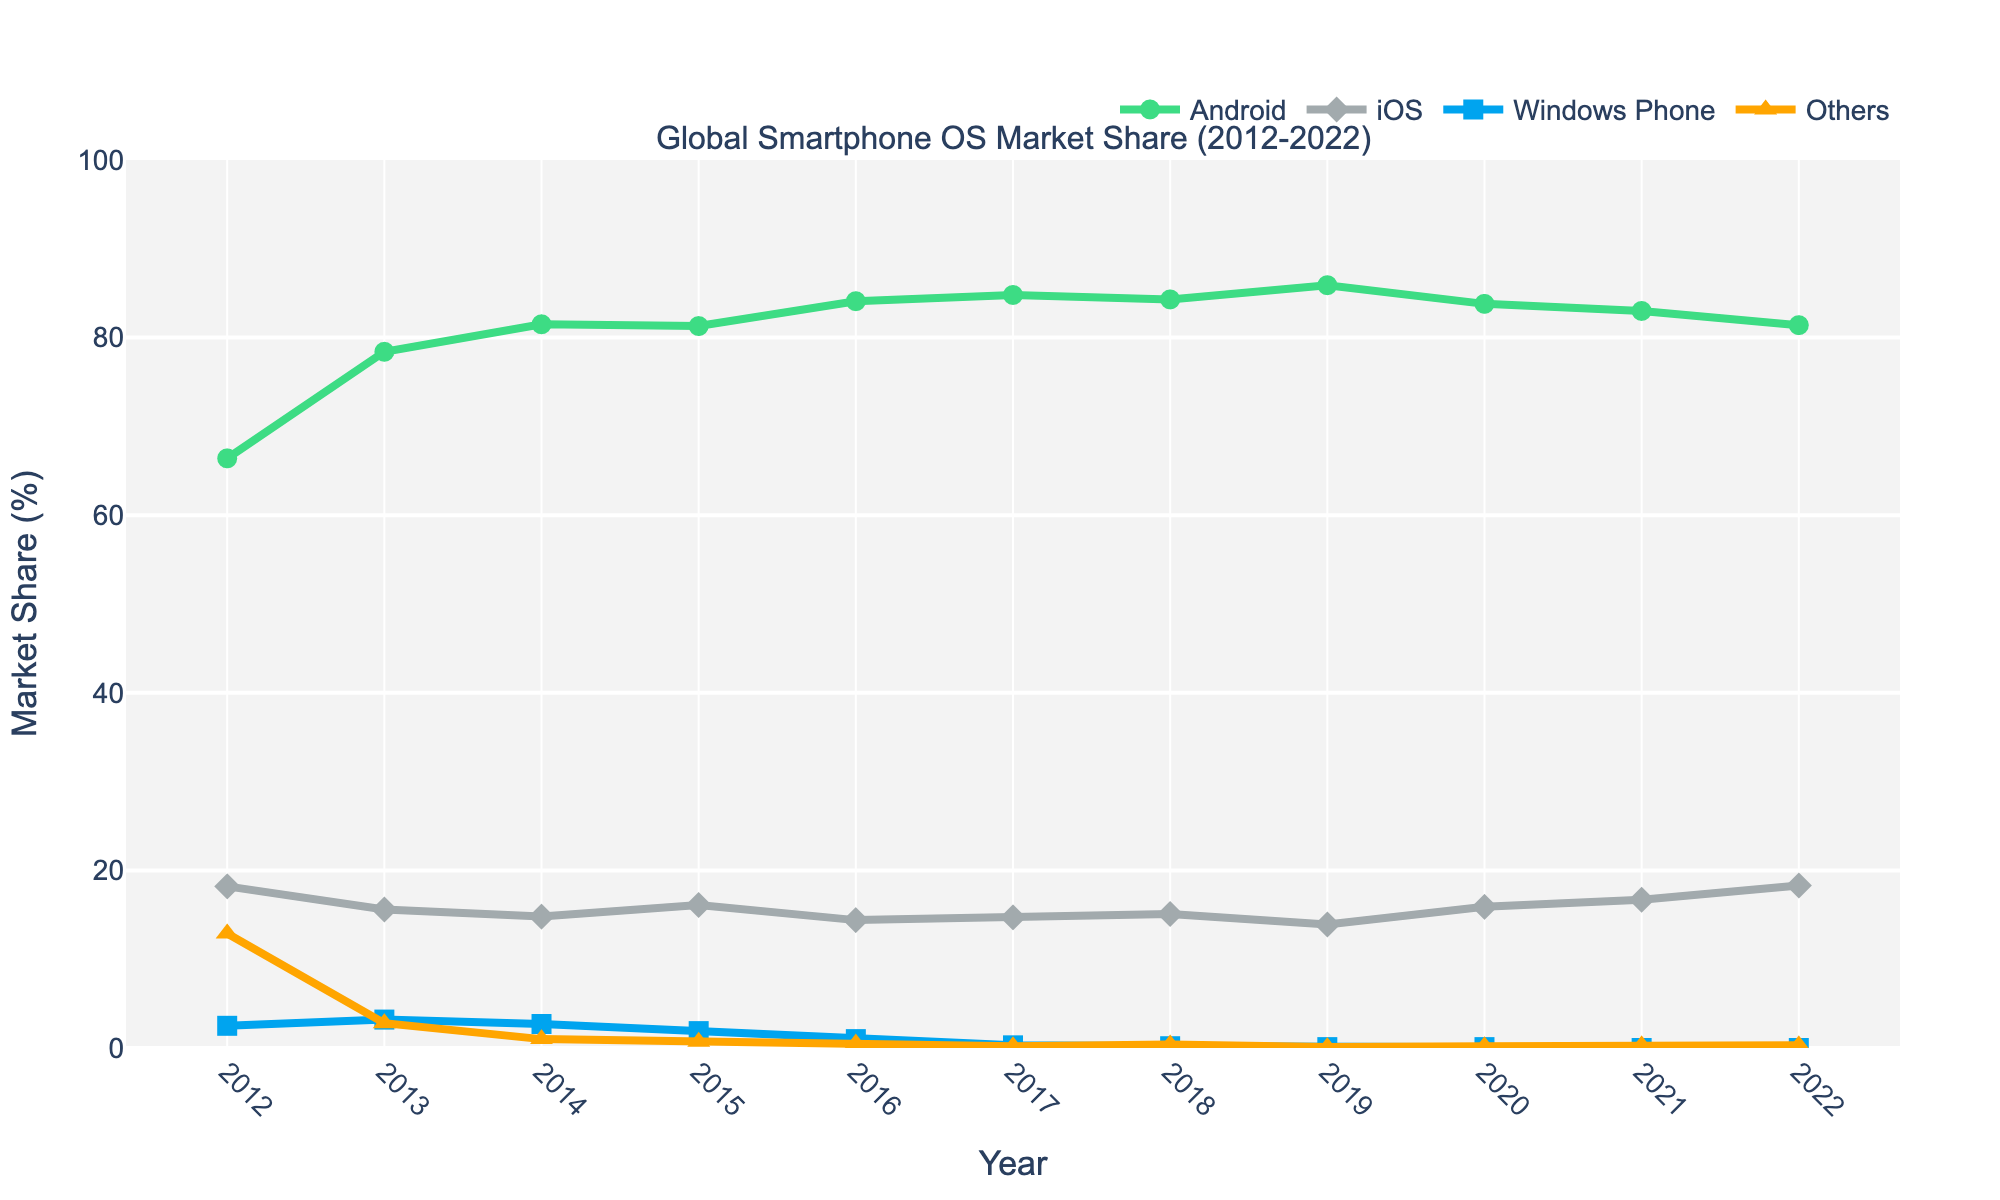What year did iOS have the highest market share? By looking at the trend line for iOS, identify the peak point in the graph. The highest market share for iOS appears in 2022.
Answer: 2022 Which operating system experienced the most significant decline in market share from 2012 to 2022? Compare the start and end points of each trend line from 2012 to 2022. Windows Phone shows the biggest drop, going from 2.5% in 2012 to 0.0% in 2022.
Answer: Windows Phone How has the market share of Android changed from 2012 to 2022? By examining the Android trend line, note the percentages in 2012 and 2022. Android increased from 66.4% in 2012 to 81.4% in 2022.
Answer: Increased Which two operating systems showed almost no change in market share from 2020 to 2022? Compare the trend lines of all operating systems between 2020 and 2022. Windows Phone and Others showed almost no change, remaining at about 0.0% and 0.2%-0.3% respectively.
Answer: Windows Phone and Others What is the sum of market shares for iOS and Android in 2021? Identify the market share of iOS (16.7%) and Android (83.0%) in 2021 and sum these values. 16.7% + 83.0% = 99.7%.
Answer: 99.7% In which year did Android surpass an 80% market share for the first time? Find the point where the Android trend line crosses the 80% mark. This happens in 2014.
Answer: 2014 Was there any year where all operating systems had perceptible shares (above 1%)? Check each year to see if all operating systems have market shares above 1%. The last year where this is true is 2013.
Answer: 2013 What is the difference in market share between iOS and Android in 2019? Note the market shares of iOS (13.9%) and Android (85.9%) in 2019. The difference is 85.9% - 13.9% = 72%.
Answer: 72% What colors represent Android and iOS in the figure? Refer to the color of the trend lines for Android and iOS. Android is represented by green and iOS by grey.
Answer: Green and Grey What trend can be observed for "Others" from 2012 to 2022? Look at the "Others" trend line throughout the years. The market share for "Others" consistently decreases from 12.9% in 2012 to about 0.3% in 2022.
Answer: Decreasing 